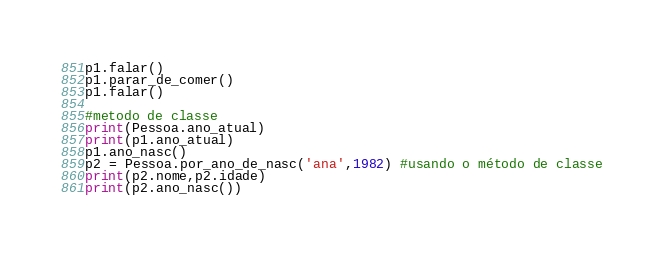Convert code to text. <code><loc_0><loc_0><loc_500><loc_500><_Python_>p1.falar()
p1.parar_de_comer()
p1.falar()

#metodo de classe
print(Pessoa.ano_atual)
print(p1.ano_atual)
p1.ano_nasc()
p2 = Pessoa.por_ano_de_nasc('ana',1982) #usando o método de classe
print(p2.nome,p2.idade)
print(p2.ano_nasc())</code> 